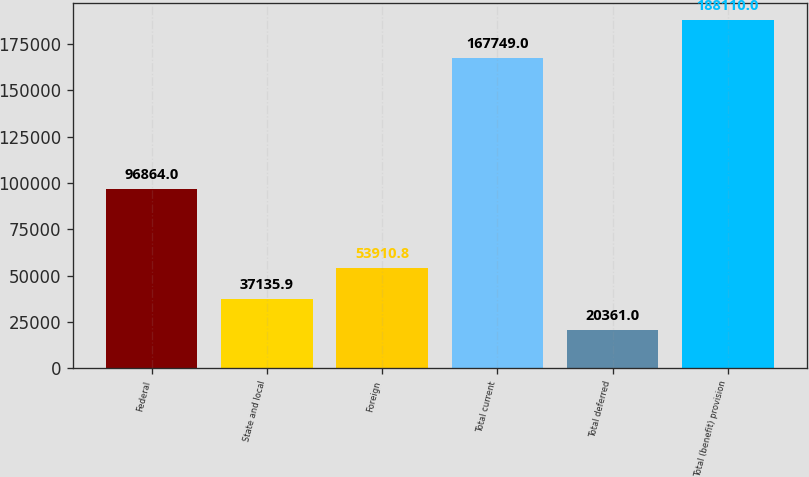Convert chart. <chart><loc_0><loc_0><loc_500><loc_500><bar_chart><fcel>Federal<fcel>State and local<fcel>Foreign<fcel>Total current<fcel>Total deferred<fcel>Total (benefit) provision<nl><fcel>96864<fcel>37135.9<fcel>53910.8<fcel>167749<fcel>20361<fcel>188110<nl></chart> 